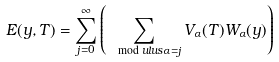Convert formula to latex. <formula><loc_0><loc_0><loc_500><loc_500>E ( y , T ) = \sum _ { j = 0 } ^ { \infty } \left ( \sum _ { \mod u l u s { \alpha } = j } V _ { \alpha } ( T ) W _ { \alpha } ( y ) \right )</formula> 